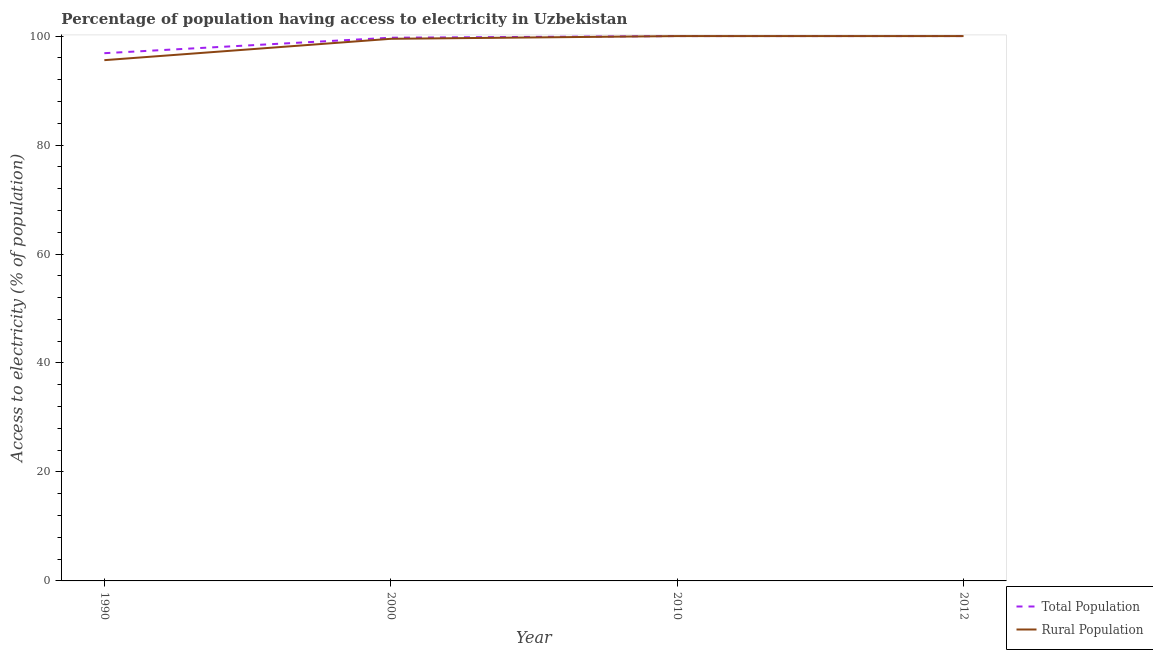How many different coloured lines are there?
Ensure brevity in your answer.  2. Does the line corresponding to percentage of population having access to electricity intersect with the line corresponding to percentage of rural population having access to electricity?
Offer a very short reply. Yes. Is the number of lines equal to the number of legend labels?
Give a very brief answer. Yes. What is the percentage of population having access to electricity in 2000?
Your answer should be compact. 99.7. Across all years, what is the minimum percentage of rural population having access to electricity?
Offer a terse response. 95.58. What is the total percentage of rural population having access to electricity in the graph?
Ensure brevity in your answer.  395.08. What is the difference between the percentage of population having access to electricity in 1990 and that in 2010?
Give a very brief answer. -3.14. What is the average percentage of rural population having access to electricity per year?
Keep it short and to the point. 98.77. In the year 1990, what is the difference between the percentage of rural population having access to electricity and percentage of population having access to electricity?
Your response must be concise. -1.28. In how many years, is the percentage of population having access to electricity greater than 96 %?
Your answer should be compact. 4. What is the ratio of the percentage of rural population having access to electricity in 1990 to that in 2012?
Keep it short and to the point. 0.96. Is the difference between the percentage of population having access to electricity in 2010 and 2012 greater than the difference between the percentage of rural population having access to electricity in 2010 and 2012?
Provide a succinct answer. No. What is the difference between the highest and the lowest percentage of rural population having access to electricity?
Provide a short and direct response. 4.42. Is the sum of the percentage of population having access to electricity in 2000 and 2012 greater than the maximum percentage of rural population having access to electricity across all years?
Keep it short and to the point. Yes. Is the percentage of rural population having access to electricity strictly greater than the percentage of population having access to electricity over the years?
Provide a succinct answer. No. How many years are there in the graph?
Give a very brief answer. 4. What is the difference between two consecutive major ticks on the Y-axis?
Your answer should be very brief. 20. Does the graph contain grids?
Offer a terse response. No. How are the legend labels stacked?
Offer a terse response. Vertical. What is the title of the graph?
Your answer should be very brief. Percentage of population having access to electricity in Uzbekistan. What is the label or title of the X-axis?
Give a very brief answer. Year. What is the label or title of the Y-axis?
Your answer should be compact. Access to electricity (% of population). What is the Access to electricity (% of population) in Total Population in 1990?
Ensure brevity in your answer.  96.86. What is the Access to electricity (% of population) of Rural Population in 1990?
Give a very brief answer. 95.58. What is the Access to electricity (% of population) of Total Population in 2000?
Offer a terse response. 99.7. What is the Access to electricity (% of population) of Rural Population in 2000?
Your answer should be compact. 99.5. What is the Access to electricity (% of population) of Total Population in 2010?
Ensure brevity in your answer.  100. What is the Access to electricity (% of population) of Total Population in 2012?
Provide a short and direct response. 100. What is the Access to electricity (% of population) of Rural Population in 2012?
Ensure brevity in your answer.  100. Across all years, what is the minimum Access to electricity (% of population) in Total Population?
Give a very brief answer. 96.86. Across all years, what is the minimum Access to electricity (% of population) of Rural Population?
Your response must be concise. 95.58. What is the total Access to electricity (% of population) in Total Population in the graph?
Provide a short and direct response. 396.56. What is the total Access to electricity (% of population) of Rural Population in the graph?
Give a very brief answer. 395.08. What is the difference between the Access to electricity (% of population) of Total Population in 1990 and that in 2000?
Provide a succinct answer. -2.84. What is the difference between the Access to electricity (% of population) in Rural Population in 1990 and that in 2000?
Make the answer very short. -3.92. What is the difference between the Access to electricity (% of population) of Total Population in 1990 and that in 2010?
Your answer should be compact. -3.14. What is the difference between the Access to electricity (% of population) in Rural Population in 1990 and that in 2010?
Offer a terse response. -4.42. What is the difference between the Access to electricity (% of population) of Total Population in 1990 and that in 2012?
Your response must be concise. -3.14. What is the difference between the Access to electricity (% of population) of Rural Population in 1990 and that in 2012?
Ensure brevity in your answer.  -4.42. What is the difference between the Access to electricity (% of population) of Rural Population in 2000 and that in 2010?
Your response must be concise. -0.5. What is the difference between the Access to electricity (% of population) of Total Population in 2000 and that in 2012?
Keep it short and to the point. -0.3. What is the difference between the Access to electricity (% of population) in Rural Population in 2010 and that in 2012?
Offer a terse response. 0. What is the difference between the Access to electricity (% of population) in Total Population in 1990 and the Access to electricity (% of population) in Rural Population in 2000?
Your answer should be compact. -2.64. What is the difference between the Access to electricity (% of population) of Total Population in 1990 and the Access to electricity (% of population) of Rural Population in 2010?
Make the answer very short. -3.14. What is the difference between the Access to electricity (% of population) of Total Population in 1990 and the Access to electricity (% of population) of Rural Population in 2012?
Provide a short and direct response. -3.14. What is the difference between the Access to electricity (% of population) of Total Population in 2000 and the Access to electricity (% of population) of Rural Population in 2012?
Your answer should be very brief. -0.3. What is the difference between the Access to electricity (% of population) in Total Population in 2010 and the Access to electricity (% of population) in Rural Population in 2012?
Your answer should be compact. 0. What is the average Access to electricity (% of population) in Total Population per year?
Offer a very short reply. 99.14. What is the average Access to electricity (% of population) in Rural Population per year?
Your response must be concise. 98.77. In the year 1990, what is the difference between the Access to electricity (% of population) of Total Population and Access to electricity (% of population) of Rural Population?
Provide a succinct answer. 1.28. In the year 2000, what is the difference between the Access to electricity (% of population) of Total Population and Access to electricity (% of population) of Rural Population?
Give a very brief answer. 0.2. In the year 2010, what is the difference between the Access to electricity (% of population) of Total Population and Access to electricity (% of population) of Rural Population?
Keep it short and to the point. 0. What is the ratio of the Access to electricity (% of population) of Total Population in 1990 to that in 2000?
Your response must be concise. 0.97. What is the ratio of the Access to electricity (% of population) in Rural Population in 1990 to that in 2000?
Provide a succinct answer. 0.96. What is the ratio of the Access to electricity (% of population) in Total Population in 1990 to that in 2010?
Your response must be concise. 0.97. What is the ratio of the Access to electricity (% of population) of Rural Population in 1990 to that in 2010?
Provide a short and direct response. 0.96. What is the ratio of the Access to electricity (% of population) of Total Population in 1990 to that in 2012?
Provide a succinct answer. 0.97. What is the ratio of the Access to electricity (% of population) in Rural Population in 1990 to that in 2012?
Offer a very short reply. 0.96. What is the ratio of the Access to electricity (% of population) of Total Population in 2000 to that in 2010?
Your response must be concise. 1. What is the ratio of the Access to electricity (% of population) in Rural Population in 2000 to that in 2010?
Your answer should be compact. 0.99. What is the ratio of the Access to electricity (% of population) in Rural Population in 2000 to that in 2012?
Offer a very short reply. 0.99. What is the ratio of the Access to electricity (% of population) in Rural Population in 2010 to that in 2012?
Provide a succinct answer. 1. What is the difference between the highest and the second highest Access to electricity (% of population) in Rural Population?
Provide a succinct answer. 0. What is the difference between the highest and the lowest Access to electricity (% of population) of Total Population?
Ensure brevity in your answer.  3.14. What is the difference between the highest and the lowest Access to electricity (% of population) in Rural Population?
Provide a short and direct response. 4.42. 